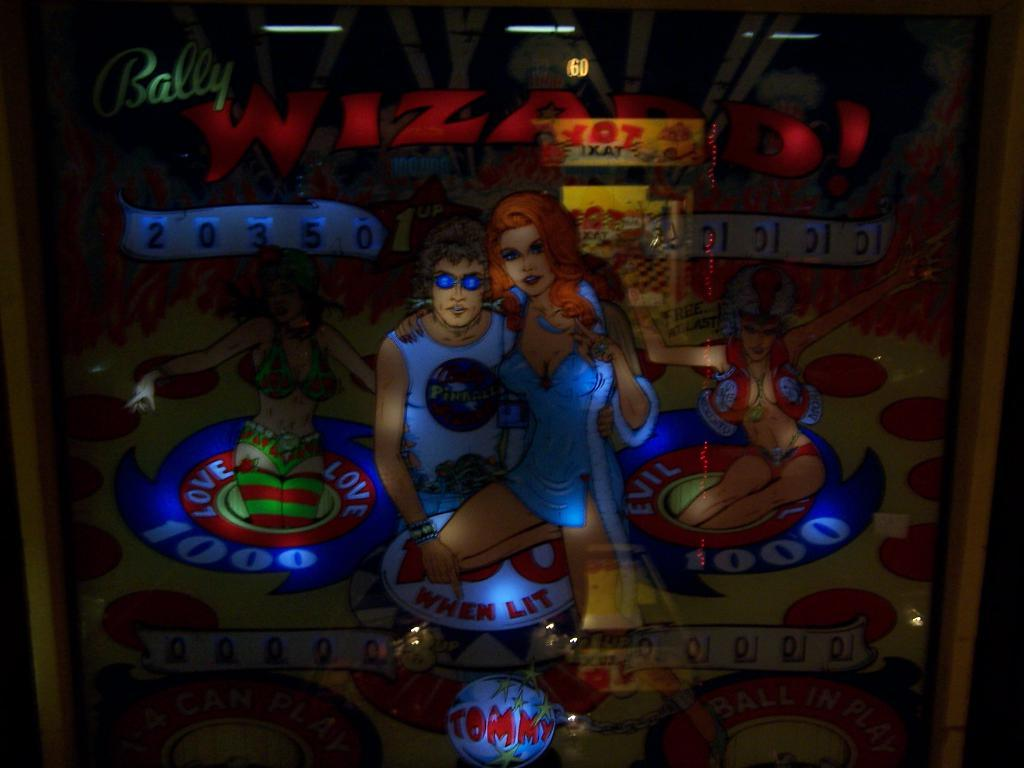<image>
Present a compact description of the photo's key features. A vintage game offers both a Love and an Evil side. 